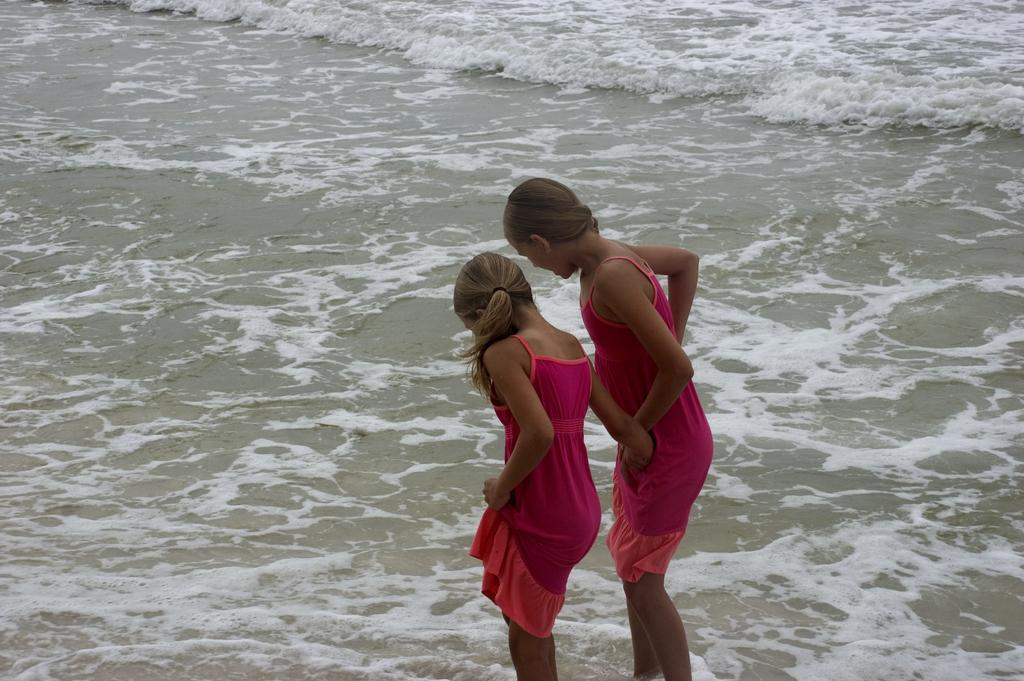How many people are in the image? There are two girls standing in the image. What can be seen at the bottom of the image? There is water visible at the bottom of the image. Where is the tub located in the image? There is no tub present in the image. What type of snack is being eaten by the girls in the image? The provided facts do not mention any snacks, including popcorn, being eaten by the girls in the image. 